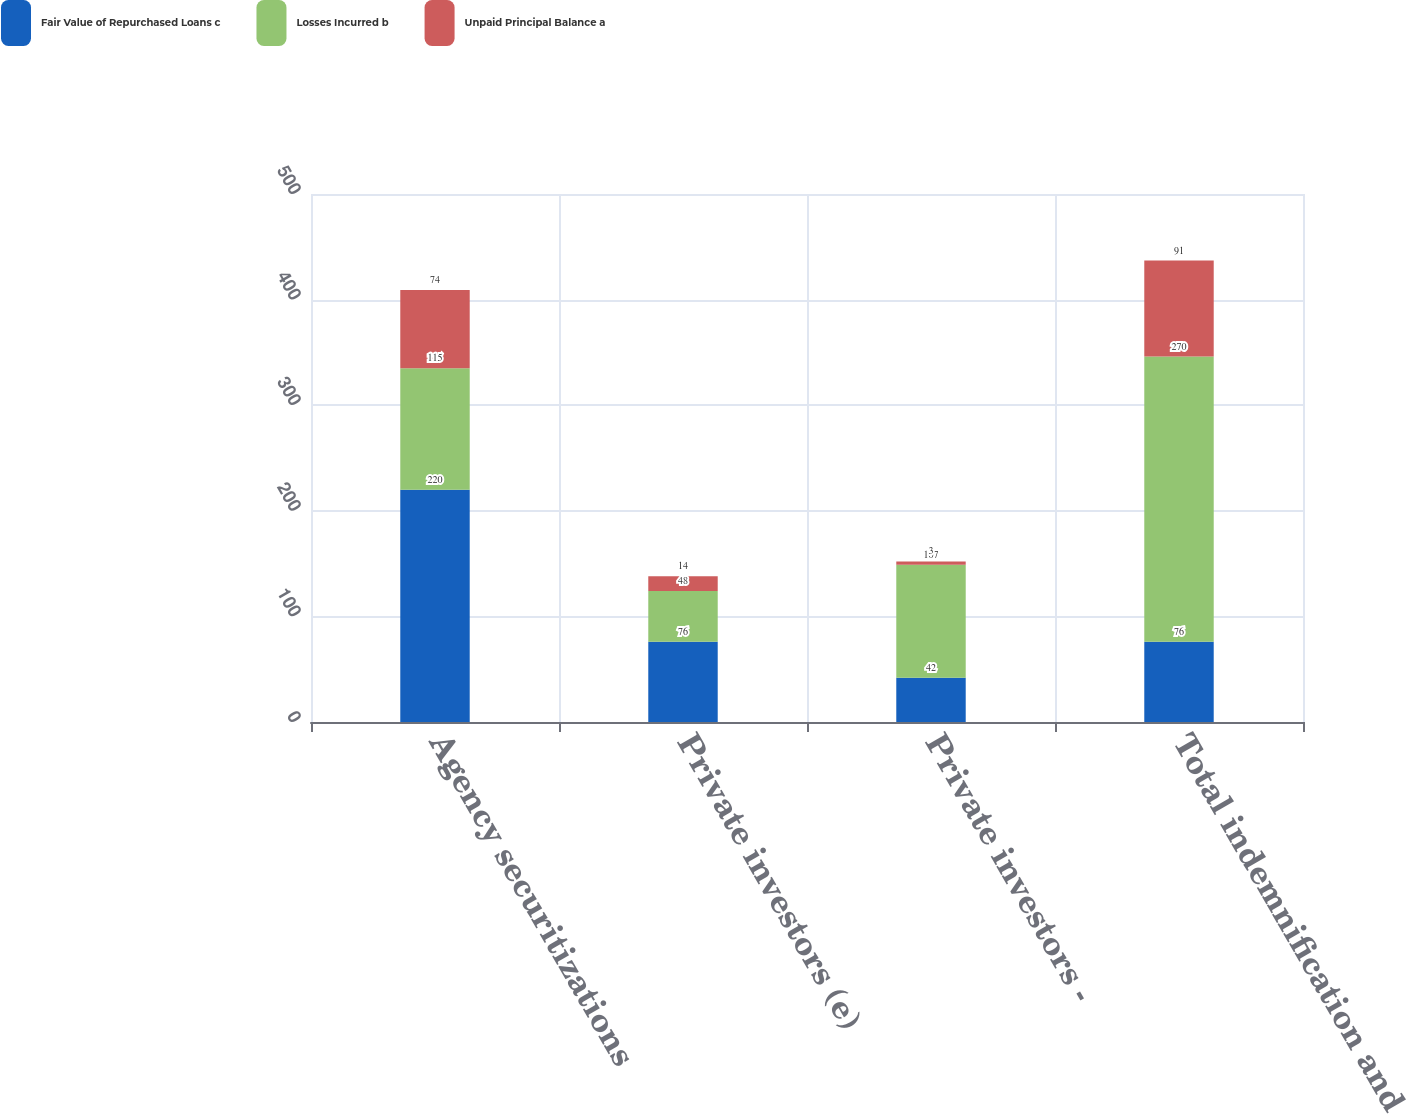Convert chart to OTSL. <chart><loc_0><loc_0><loc_500><loc_500><stacked_bar_chart><ecel><fcel>Agency securitizations<fcel>Private investors (e)<fcel>Private investors -<fcel>Total indemnification and<nl><fcel>Fair Value of Repurchased Loans c<fcel>220<fcel>76<fcel>42<fcel>76<nl><fcel>Losses Incurred b<fcel>115<fcel>48<fcel>107<fcel>270<nl><fcel>Unpaid Principal Balance a<fcel>74<fcel>14<fcel>3<fcel>91<nl></chart> 